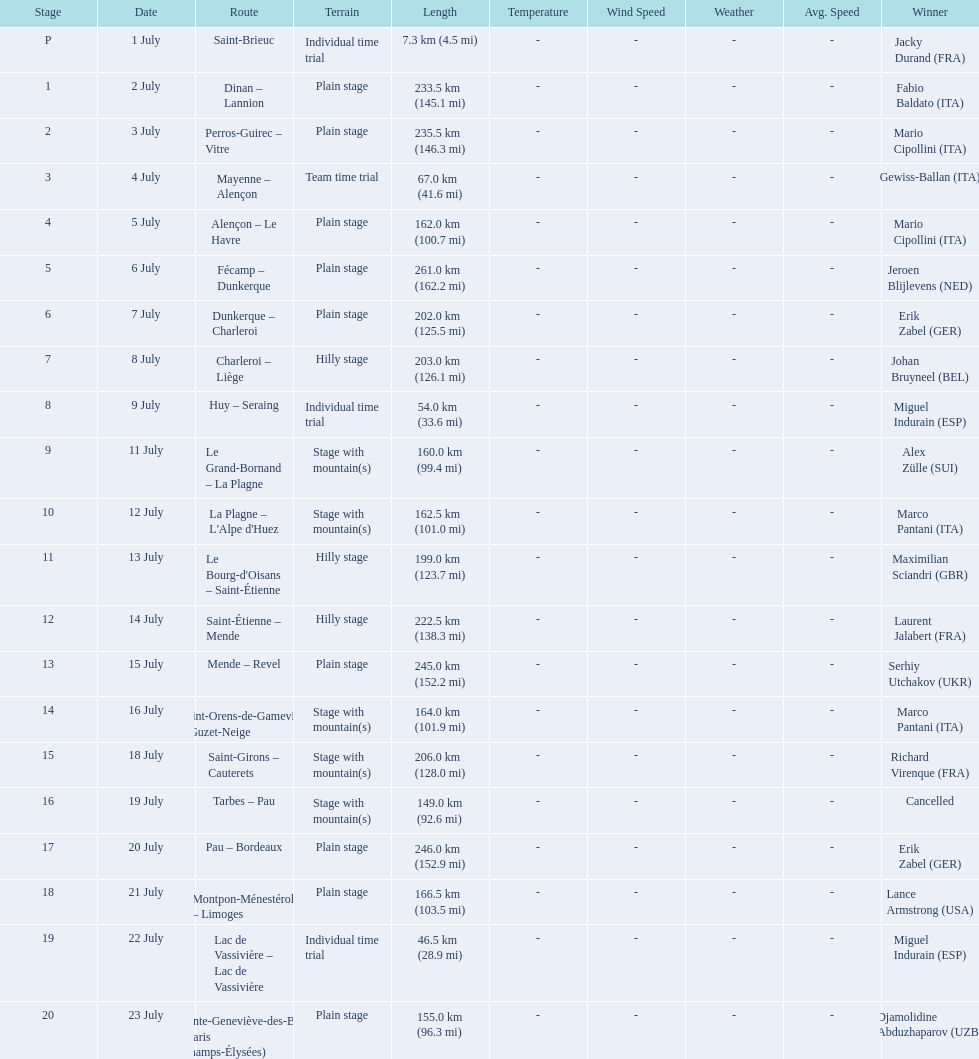Which country had more stage-winners than any other country? Italy. 